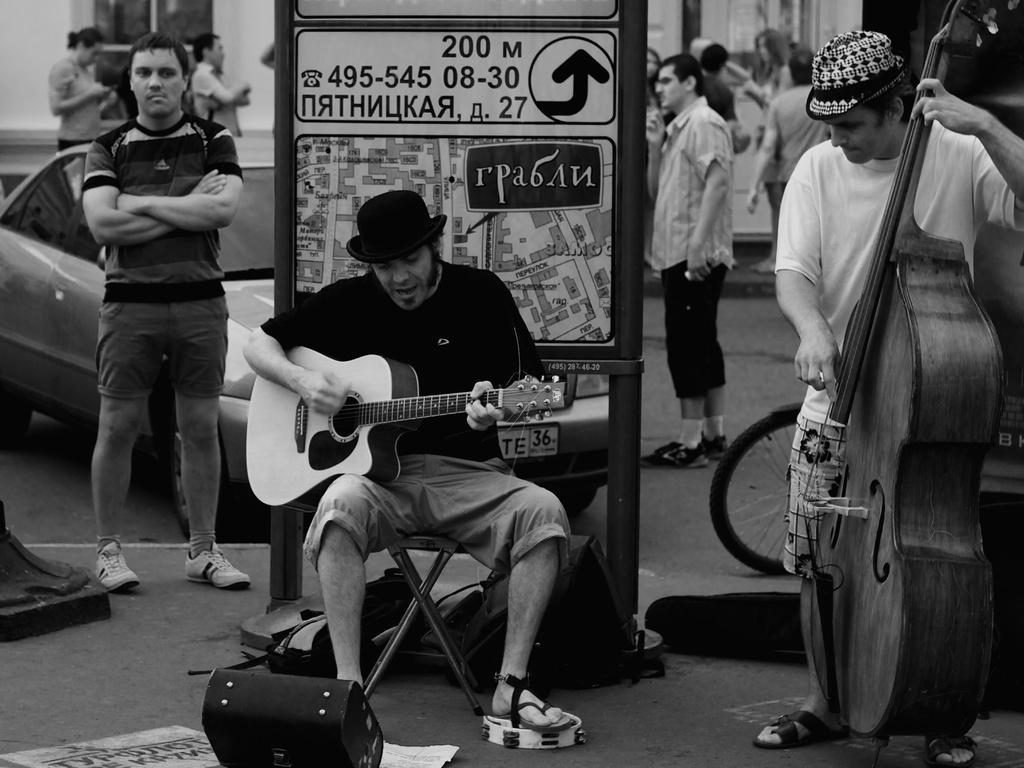Can you describe this image briefly? Person playing guitar,in the back there is car,another person standing this is poster and these is vehicle. 